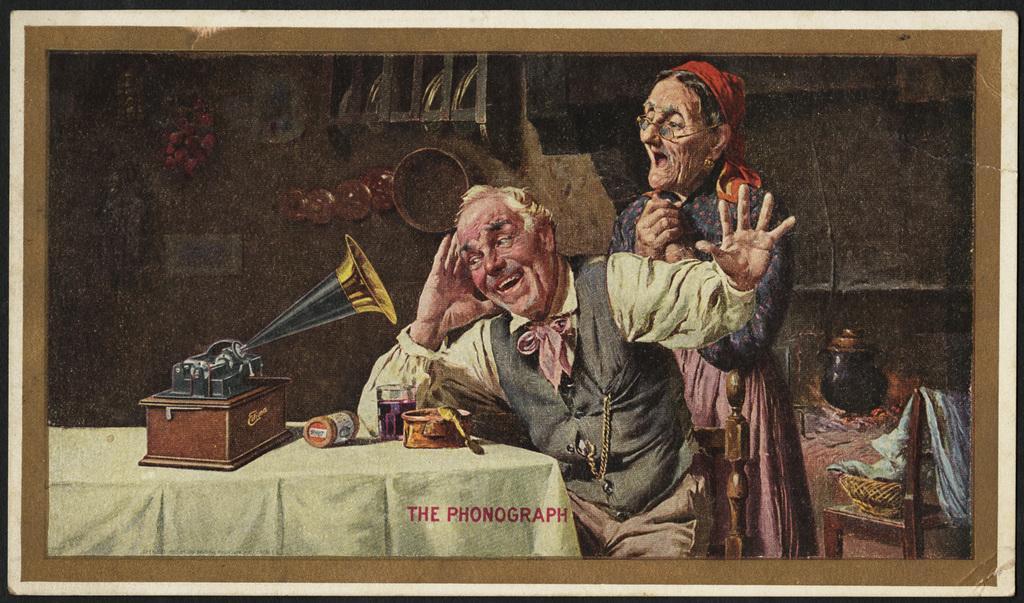How would you summarize this image in a sentence or two? This is the picture of the photo frame. In this picture, we see the old man is sitting on the chair. Behind him, we see the old woman is standing. In front of him, we see a table on which musical instrument, a glass containing liquid and some other objects are placed. On the right side, we see a pot and a chair on which basket is placed. In the background, we see a brown wall and a rack. 